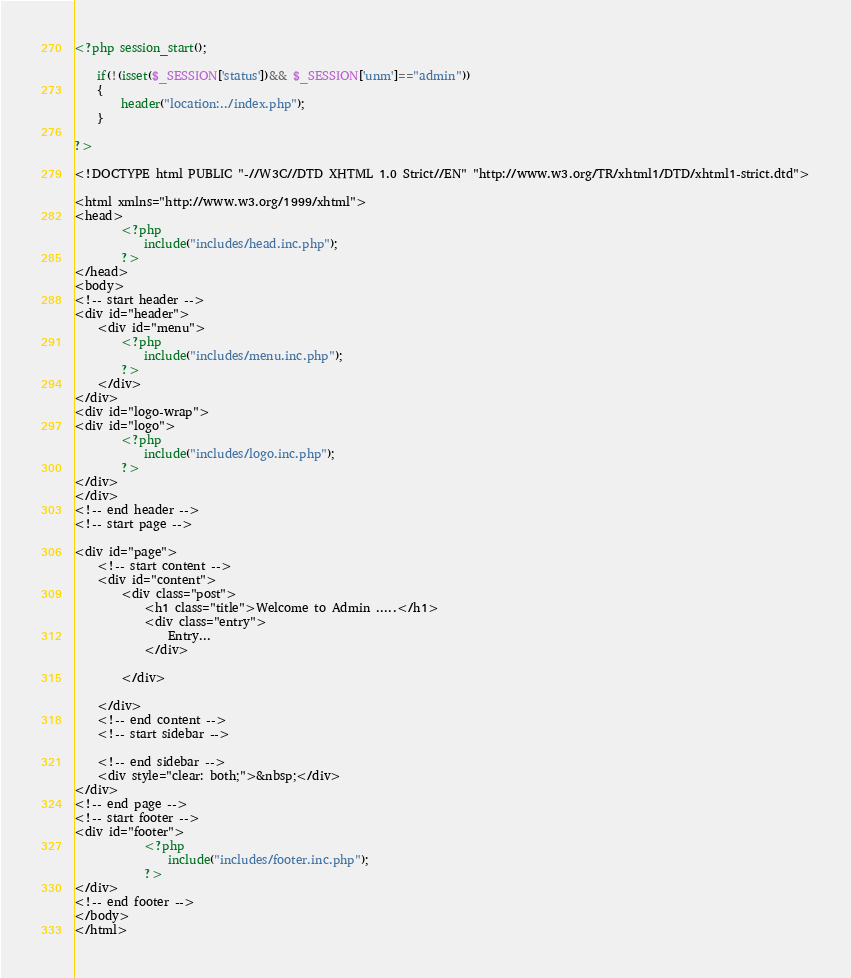Convert code to text. <code><loc_0><loc_0><loc_500><loc_500><_PHP_><?php session_start();

	if(!(isset($_SESSION['status'])&& $_SESSION['unm']=="admin"))
	{
		header("location:../index.php");
	}

?>

<!DOCTYPE html PUBLIC "-//W3C//DTD XHTML 1.0 Strict//EN" "http://www.w3.org/TR/xhtml1/DTD/xhtml1-strict.dtd">

<html xmlns="http://www.w3.org/1999/xhtml">
<head>
		<?php
			include("includes/head.inc.php");
		?>
</head>
<body>
<!-- start header -->
<div id="header">
	<div id="menu">
		<?php
			include("includes/menu.inc.php");
		?>
	</div>
</div>
<div id="logo-wrap">
<div id="logo">
		<?php
			include("includes/logo.inc.php");
		?>
</div>
</div>
<!-- end header -->
<!-- start page -->

<div id="page">
	<!-- start content -->
	<div id="content">
		<div class="post">
			<h1 class="title">Welcome to Admin .....</h1>
			<div class="entry">
				Entry...
			</div>
			
		</div>
		
	</div>
	<!-- end content -->
	<!-- start sidebar -->
	
	<!-- end sidebar -->
	<div style="clear: both;">&nbsp;</div>
</div>
<!-- end page -->
<!-- start footer -->
<div id="footer">
			<?php
				include("includes/footer.inc.php");
			?>
</div>
<!-- end footer -->
</body>
</html>
</code> 